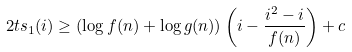Convert formula to latex. <formula><loc_0><loc_0><loc_500><loc_500>2 t s _ { 1 } ( i ) \geq ( \log f ( n ) + \log g ( n ) ) \left ( i - \frac { i ^ { 2 } - i } { f ( n ) } \right ) + c</formula> 